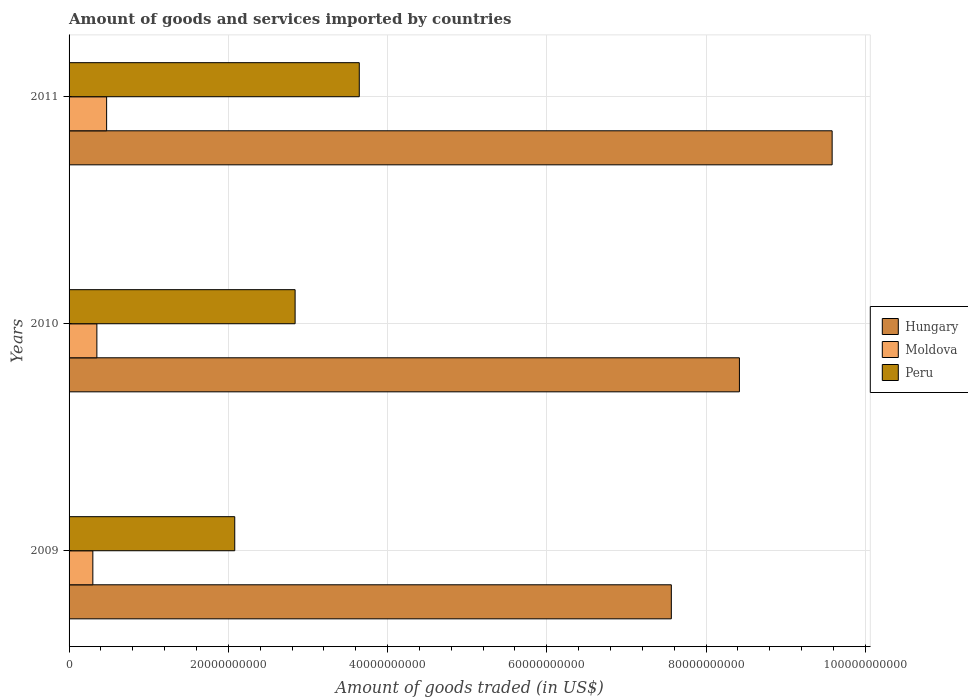How many different coloured bars are there?
Your response must be concise. 3. How many groups of bars are there?
Make the answer very short. 3. Are the number of bars on each tick of the Y-axis equal?
Your answer should be compact. Yes. How many bars are there on the 3rd tick from the bottom?
Your response must be concise. 3. What is the total amount of goods and services imported in Peru in 2010?
Your answer should be very brief. 2.84e+1. Across all years, what is the maximum total amount of goods and services imported in Hungary?
Give a very brief answer. 9.58e+1. Across all years, what is the minimum total amount of goods and services imported in Hungary?
Your answer should be very brief. 7.56e+1. In which year was the total amount of goods and services imported in Peru maximum?
Give a very brief answer. 2011. In which year was the total amount of goods and services imported in Peru minimum?
Make the answer very short. 2009. What is the total total amount of goods and services imported in Moldova in the graph?
Offer a very short reply. 1.12e+1. What is the difference between the total amount of goods and services imported in Hungary in 2009 and that in 2011?
Offer a very short reply. -2.02e+1. What is the difference between the total amount of goods and services imported in Peru in 2010 and the total amount of goods and services imported in Hungary in 2011?
Your answer should be compact. -6.74e+1. What is the average total amount of goods and services imported in Moldova per year?
Your answer should be compact. 3.73e+09. In the year 2010, what is the difference between the total amount of goods and services imported in Peru and total amount of goods and services imported in Hungary?
Offer a terse response. -5.58e+1. In how many years, is the total amount of goods and services imported in Peru greater than 44000000000 US$?
Your answer should be compact. 0. What is the ratio of the total amount of goods and services imported in Moldova in 2010 to that in 2011?
Provide a short and direct response. 0.74. Is the total amount of goods and services imported in Moldova in 2009 less than that in 2011?
Give a very brief answer. Yes. What is the difference between the highest and the second highest total amount of goods and services imported in Moldova?
Provide a short and direct response. 1.22e+09. What is the difference between the highest and the lowest total amount of goods and services imported in Moldova?
Give a very brief answer. 1.73e+09. Is the sum of the total amount of goods and services imported in Peru in 2009 and 2011 greater than the maximum total amount of goods and services imported in Hungary across all years?
Keep it short and to the point. No. What does the 1st bar from the top in 2011 represents?
Provide a succinct answer. Peru. What does the 2nd bar from the bottom in 2011 represents?
Your answer should be compact. Moldova. What is the difference between two consecutive major ticks on the X-axis?
Make the answer very short. 2.00e+1. Does the graph contain any zero values?
Provide a succinct answer. No. Where does the legend appear in the graph?
Your answer should be compact. Center right. How are the legend labels stacked?
Give a very brief answer. Vertical. What is the title of the graph?
Offer a very short reply. Amount of goods and services imported by countries. What is the label or title of the X-axis?
Offer a very short reply. Amount of goods traded (in US$). What is the Amount of goods traded (in US$) of Hungary in 2009?
Make the answer very short. 7.56e+1. What is the Amount of goods traded (in US$) in Moldova in 2009?
Ensure brevity in your answer.  2.99e+09. What is the Amount of goods traded (in US$) of Peru in 2009?
Offer a terse response. 2.08e+1. What is the Amount of goods traded (in US$) in Hungary in 2010?
Ensure brevity in your answer.  8.42e+1. What is the Amount of goods traded (in US$) of Moldova in 2010?
Offer a very short reply. 3.49e+09. What is the Amount of goods traded (in US$) of Peru in 2010?
Your response must be concise. 2.84e+1. What is the Amount of goods traded (in US$) of Hungary in 2011?
Your answer should be compact. 9.58e+1. What is the Amount of goods traded (in US$) of Moldova in 2011?
Ensure brevity in your answer.  4.72e+09. What is the Amount of goods traded (in US$) of Peru in 2011?
Ensure brevity in your answer.  3.64e+1. Across all years, what is the maximum Amount of goods traded (in US$) of Hungary?
Your answer should be very brief. 9.58e+1. Across all years, what is the maximum Amount of goods traded (in US$) in Moldova?
Offer a terse response. 4.72e+09. Across all years, what is the maximum Amount of goods traded (in US$) of Peru?
Make the answer very short. 3.64e+1. Across all years, what is the minimum Amount of goods traded (in US$) of Hungary?
Your response must be concise. 7.56e+1. Across all years, what is the minimum Amount of goods traded (in US$) in Moldova?
Make the answer very short. 2.99e+09. Across all years, what is the minimum Amount of goods traded (in US$) of Peru?
Ensure brevity in your answer.  2.08e+1. What is the total Amount of goods traded (in US$) in Hungary in the graph?
Give a very brief answer. 2.56e+11. What is the total Amount of goods traded (in US$) of Moldova in the graph?
Provide a succinct answer. 1.12e+1. What is the total Amount of goods traded (in US$) of Peru in the graph?
Your answer should be very brief. 8.56e+1. What is the difference between the Amount of goods traded (in US$) of Hungary in 2009 and that in 2010?
Make the answer very short. -8.55e+09. What is the difference between the Amount of goods traded (in US$) in Moldova in 2009 and that in 2010?
Offer a terse response. -5.05e+08. What is the difference between the Amount of goods traded (in US$) of Peru in 2009 and that in 2010?
Keep it short and to the point. -7.58e+09. What is the difference between the Amount of goods traded (in US$) in Hungary in 2009 and that in 2011?
Your answer should be very brief. -2.02e+1. What is the difference between the Amount of goods traded (in US$) of Moldova in 2009 and that in 2011?
Give a very brief answer. -1.73e+09. What is the difference between the Amount of goods traded (in US$) in Peru in 2009 and that in 2011?
Your answer should be very brief. -1.56e+1. What is the difference between the Amount of goods traded (in US$) of Hungary in 2010 and that in 2011?
Your answer should be compact. -1.16e+1. What is the difference between the Amount of goods traded (in US$) in Moldova in 2010 and that in 2011?
Your answer should be very brief. -1.22e+09. What is the difference between the Amount of goods traded (in US$) of Peru in 2010 and that in 2011?
Ensure brevity in your answer.  -8.06e+09. What is the difference between the Amount of goods traded (in US$) in Hungary in 2009 and the Amount of goods traded (in US$) in Moldova in 2010?
Offer a very short reply. 7.22e+1. What is the difference between the Amount of goods traded (in US$) in Hungary in 2009 and the Amount of goods traded (in US$) in Peru in 2010?
Provide a succinct answer. 4.73e+1. What is the difference between the Amount of goods traded (in US$) in Moldova in 2009 and the Amount of goods traded (in US$) in Peru in 2010?
Your answer should be compact. -2.54e+1. What is the difference between the Amount of goods traded (in US$) in Hungary in 2009 and the Amount of goods traded (in US$) in Moldova in 2011?
Your answer should be very brief. 7.09e+1. What is the difference between the Amount of goods traded (in US$) of Hungary in 2009 and the Amount of goods traded (in US$) of Peru in 2011?
Provide a short and direct response. 3.92e+1. What is the difference between the Amount of goods traded (in US$) of Moldova in 2009 and the Amount of goods traded (in US$) of Peru in 2011?
Ensure brevity in your answer.  -3.35e+1. What is the difference between the Amount of goods traded (in US$) of Hungary in 2010 and the Amount of goods traded (in US$) of Moldova in 2011?
Your answer should be compact. 7.95e+1. What is the difference between the Amount of goods traded (in US$) of Hungary in 2010 and the Amount of goods traded (in US$) of Peru in 2011?
Make the answer very short. 4.77e+1. What is the difference between the Amount of goods traded (in US$) of Moldova in 2010 and the Amount of goods traded (in US$) of Peru in 2011?
Your answer should be compact. -3.30e+1. What is the average Amount of goods traded (in US$) of Hungary per year?
Give a very brief answer. 8.52e+1. What is the average Amount of goods traded (in US$) in Moldova per year?
Make the answer very short. 3.73e+09. What is the average Amount of goods traded (in US$) of Peru per year?
Offer a terse response. 2.85e+1. In the year 2009, what is the difference between the Amount of goods traded (in US$) in Hungary and Amount of goods traded (in US$) in Moldova?
Ensure brevity in your answer.  7.27e+1. In the year 2009, what is the difference between the Amount of goods traded (in US$) of Hungary and Amount of goods traded (in US$) of Peru?
Your response must be concise. 5.48e+1. In the year 2009, what is the difference between the Amount of goods traded (in US$) in Moldova and Amount of goods traded (in US$) in Peru?
Offer a terse response. -1.78e+1. In the year 2010, what is the difference between the Amount of goods traded (in US$) in Hungary and Amount of goods traded (in US$) in Moldova?
Ensure brevity in your answer.  8.07e+1. In the year 2010, what is the difference between the Amount of goods traded (in US$) in Hungary and Amount of goods traded (in US$) in Peru?
Make the answer very short. 5.58e+1. In the year 2010, what is the difference between the Amount of goods traded (in US$) in Moldova and Amount of goods traded (in US$) in Peru?
Make the answer very short. -2.49e+1. In the year 2011, what is the difference between the Amount of goods traded (in US$) in Hungary and Amount of goods traded (in US$) in Moldova?
Ensure brevity in your answer.  9.11e+1. In the year 2011, what is the difference between the Amount of goods traded (in US$) in Hungary and Amount of goods traded (in US$) in Peru?
Your answer should be compact. 5.94e+1. In the year 2011, what is the difference between the Amount of goods traded (in US$) of Moldova and Amount of goods traded (in US$) of Peru?
Offer a very short reply. -3.17e+1. What is the ratio of the Amount of goods traded (in US$) of Hungary in 2009 to that in 2010?
Keep it short and to the point. 0.9. What is the ratio of the Amount of goods traded (in US$) in Moldova in 2009 to that in 2010?
Ensure brevity in your answer.  0.86. What is the ratio of the Amount of goods traded (in US$) in Peru in 2009 to that in 2010?
Offer a terse response. 0.73. What is the ratio of the Amount of goods traded (in US$) in Hungary in 2009 to that in 2011?
Keep it short and to the point. 0.79. What is the ratio of the Amount of goods traded (in US$) of Moldova in 2009 to that in 2011?
Your response must be concise. 0.63. What is the ratio of the Amount of goods traded (in US$) of Peru in 2009 to that in 2011?
Offer a very short reply. 0.57. What is the ratio of the Amount of goods traded (in US$) in Hungary in 2010 to that in 2011?
Provide a succinct answer. 0.88. What is the ratio of the Amount of goods traded (in US$) in Moldova in 2010 to that in 2011?
Your answer should be compact. 0.74. What is the ratio of the Amount of goods traded (in US$) of Peru in 2010 to that in 2011?
Offer a very short reply. 0.78. What is the difference between the highest and the second highest Amount of goods traded (in US$) of Hungary?
Provide a short and direct response. 1.16e+1. What is the difference between the highest and the second highest Amount of goods traded (in US$) of Moldova?
Your response must be concise. 1.22e+09. What is the difference between the highest and the second highest Amount of goods traded (in US$) of Peru?
Offer a very short reply. 8.06e+09. What is the difference between the highest and the lowest Amount of goods traded (in US$) in Hungary?
Offer a very short reply. 2.02e+1. What is the difference between the highest and the lowest Amount of goods traded (in US$) of Moldova?
Provide a short and direct response. 1.73e+09. What is the difference between the highest and the lowest Amount of goods traded (in US$) of Peru?
Your answer should be very brief. 1.56e+1. 